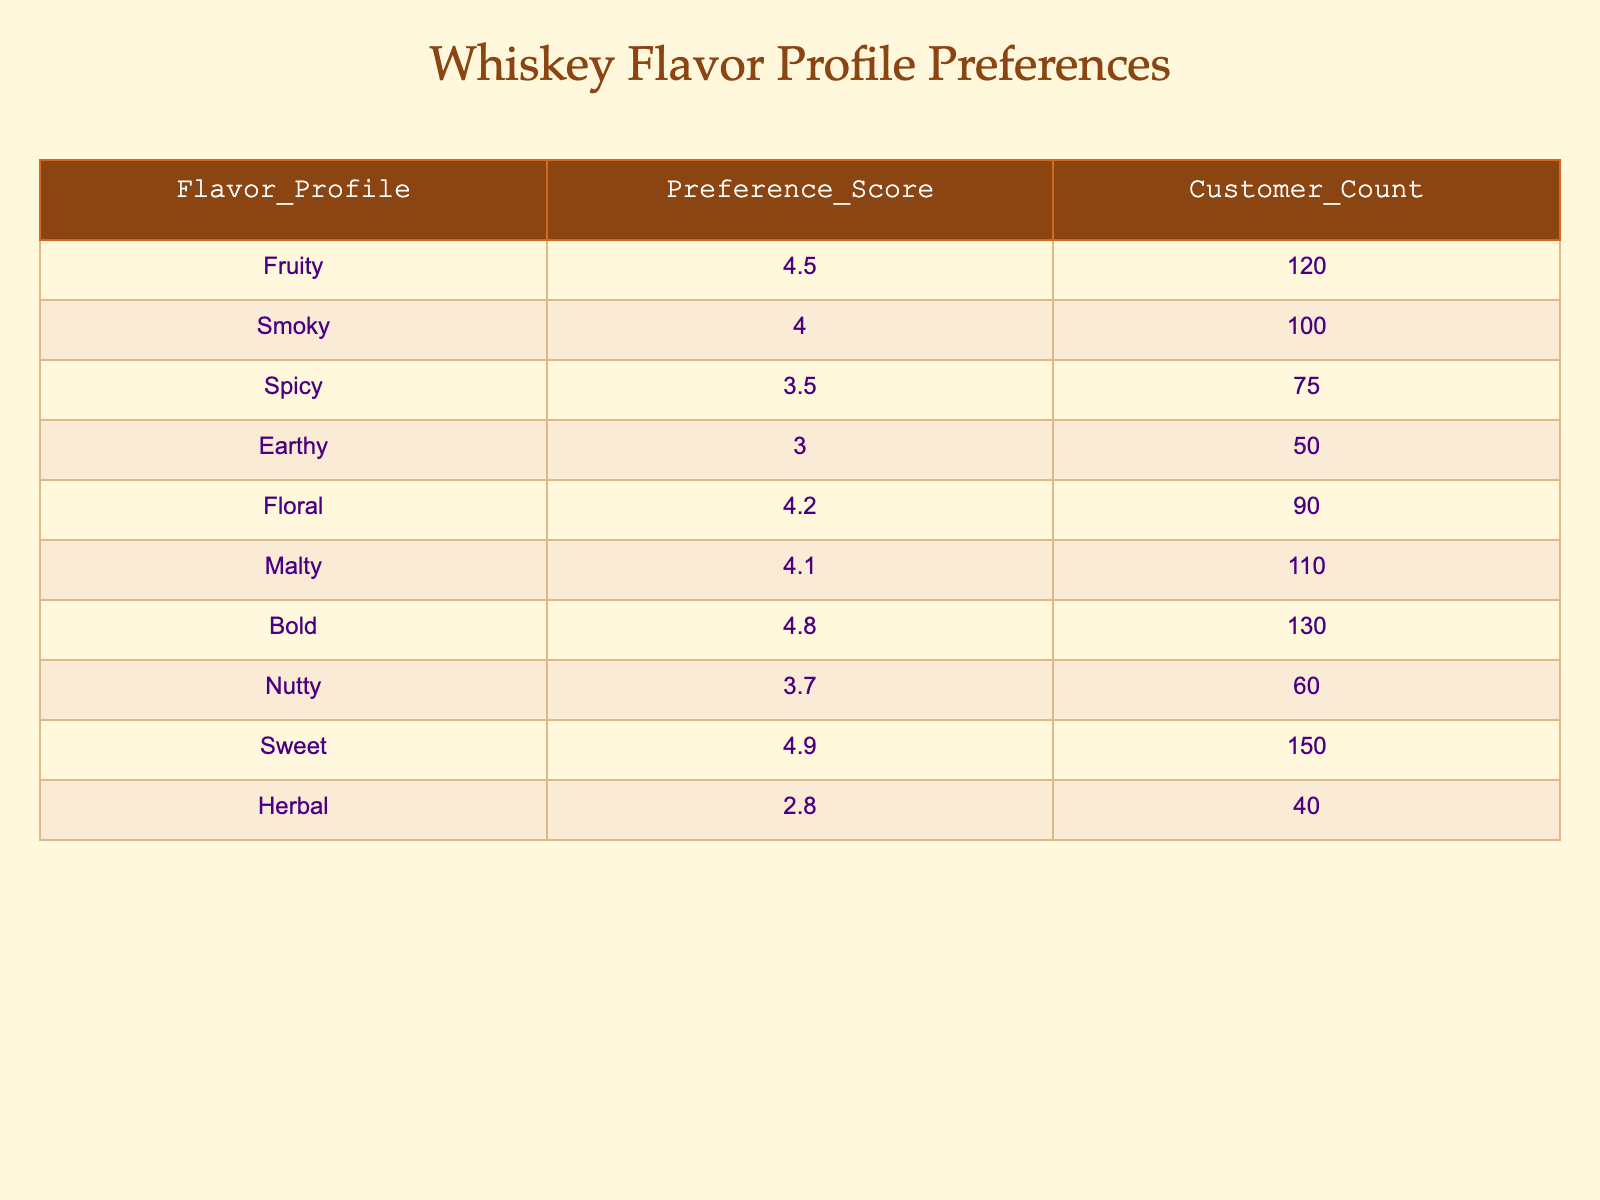What is the preference score for the sweet flavor profile? Looking at the table, the sweet flavor profile has a preference score listed under the "Preference_Score" column. The value is 4.9.
Answer: 4.9 Which flavor profile has the highest customer count? The flavor profiles listed have different customer counts. By scanning the "Customer_Count" column, the highest value is 150, associated with the sweet flavor profile.
Answer: Sweet What is the average preference score of the fruity and floral flavor profiles? The preference scores for fruity and floral are 4.5 and 4.2 respectively. To find the average: (4.5 + 4.2) / 2 = 4.35.
Answer: 4.35 Is the herbal flavor profile preferred more than the earthy flavor profile? The preference score for herbal is 2.8, and for earthy it is 3.0. Since 2.8 is less than 3.0, herbal is not preferred more than earthy.
Answer: No What is the total customer count for flavor profiles rated above 4.0? The flavor profiles with scores above 4.0 are fruity (120), smoky (100), floral (90), malty (110), bold (130), and sweet (150). Adding these: 120 + 100 + 90 + 110 + 130 + 150 = 800.
Answer: 800 Which flavor profile has a preference score closest to 4.0? The preference scores close to 4.0 are smoky (4.0), spicy (3.5), and nutty (3.7). Smoky has an exact score of 4.0, which is the closest.
Answer: Smoky What is the difference in preference scores between the bold and nutty profiles? The bold flavor profile has a score of 4.8 and nutty has a score of 3.7. To find the difference: 4.8 - 3.7 = 1.1.
Answer: 1.1 How many flavor profiles have a preference score of 4.0 or higher? The flavor profiles with scores of 4.0 or higher are fruity (4.5), smoky (4.0), floral (4.2), malty (4.1), bold (4.8), and sweet (4.9). Counting these gives us 6 profiles.
Answer: 6 What percentage of customers prefer the sweet flavor profile compared to the total customer count? The total customer count is 120 (fruity) + 100 (smoky) + 75 (spicy) + 50 (earthy) + 90 (floral) + 110 (malty) + 130 (bold) + 60 (nutty) + 150 (sweet) + 40 (herbal) = 975. The count for sweet is 150. The percentage is (150 / 975) * 100 = 15.38%.
Answer: 15.38% 